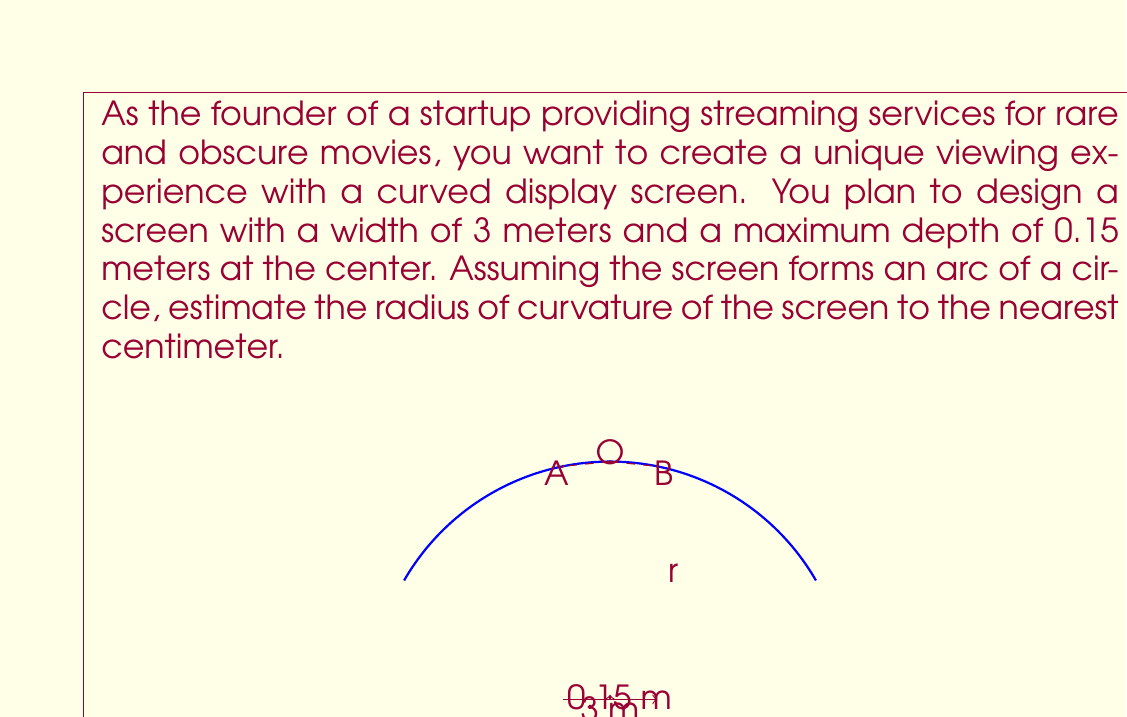Help me with this question. Let's approach this step-by-step using circular trigonometry:

1) Let the radius of the circle be $r$ meters. We need to find $r$.

2) The chord of the arc (width of the screen) is 3 meters, so half of this is 1.5 meters.

3) The depth of the screen at the center is 0.15 meters.

4) We can create a right triangle where:
   - The hypotenuse is the radius $r$
   - One side is $r - 0.15$
   - The other side is 1.5

5) Using the Pythagorean theorem:

   $$(r - 0.15)^2 + 1.5^2 = r^2$$

6) Expanding this:

   $$r^2 - 0.3r + 0.0225 + 2.25 = r^2$$

7) Simplifying:

   $$-0.3r + 2.2725 = 0$$

8) Solving for $r$:

   $$r = \frac{2.2725}{0.3} = 7.575$$

Therefore, the radius of curvature is approximately 7.58 meters or 758 cm.
Answer: 758 cm 